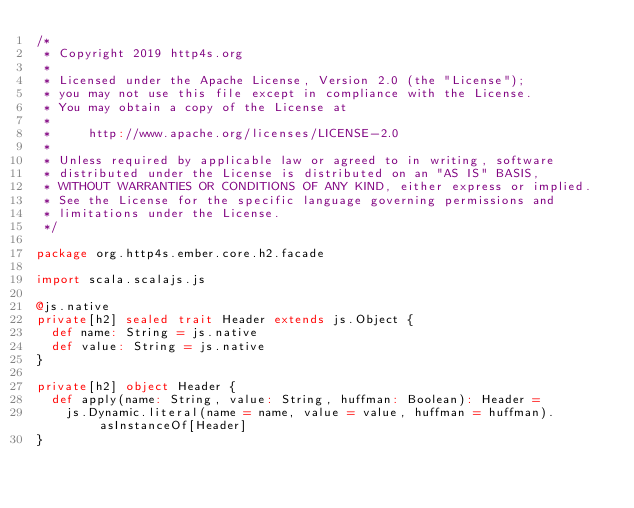Convert code to text. <code><loc_0><loc_0><loc_500><loc_500><_Scala_>/*
 * Copyright 2019 http4s.org
 *
 * Licensed under the Apache License, Version 2.0 (the "License");
 * you may not use this file except in compliance with the License.
 * You may obtain a copy of the License at
 *
 *     http://www.apache.org/licenses/LICENSE-2.0
 *
 * Unless required by applicable law or agreed to in writing, software
 * distributed under the License is distributed on an "AS IS" BASIS,
 * WITHOUT WARRANTIES OR CONDITIONS OF ANY KIND, either express or implied.
 * See the License for the specific language governing permissions and
 * limitations under the License.
 */

package org.http4s.ember.core.h2.facade

import scala.scalajs.js

@js.native
private[h2] sealed trait Header extends js.Object {
  def name: String = js.native
  def value: String = js.native
}

private[h2] object Header {
  def apply(name: String, value: String, huffman: Boolean): Header =
    js.Dynamic.literal(name = name, value = value, huffman = huffman).asInstanceOf[Header]
}
</code> 